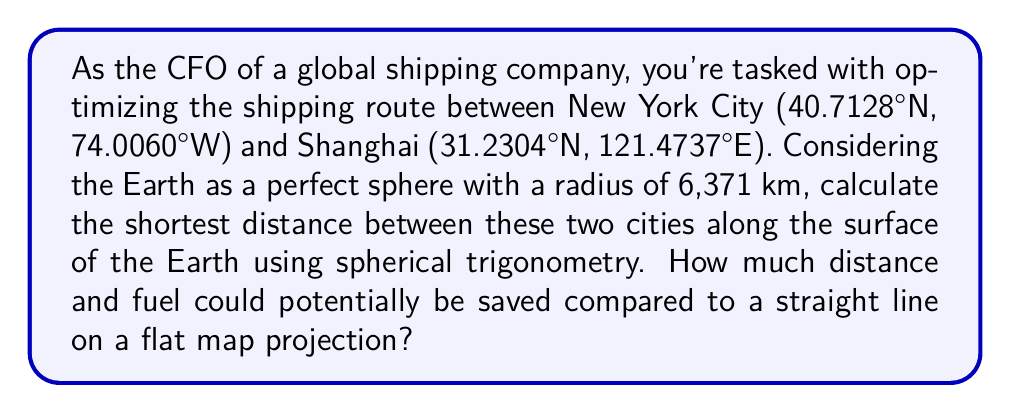Help me with this question. To solve this problem, we'll use the spherical law of cosines and compare the result to the distance on a flat map projection.

1. Convert the coordinates to radians:
   New York: $\phi_1 = 40.7128° \times \frac{\pi}{180} = 0.7101$ rad, $\lambda_1 = -74.0060° \times \frac{\pi}{180} = -1.2915$ rad
   Shanghai: $\phi_2 = 31.2304° \times \frac{\pi}{180} = 0.5451$ rad, $\lambda_2 = 121.4737° \times \frac{\pi}{180} = 2.1199$ rad

2. Calculate the central angle $\Delta\sigma$ using the spherical law of cosines:
   $$\cos(\Delta\sigma) = \sin(\phi_1)\sin(\phi_2) + \cos(\phi_1)\cos(\phi_2)\cos(\lambda_2 - \lambda_1)$$
   $$\Delta\sigma = \arccos(\sin(0.7101)\sin(0.5451) + \cos(0.7101)\cos(0.5451)\cos(2.1199 - (-1.2915)))$$
   $$\Delta\sigma = \arccos(0.1468) = 1.4238 \text{ rad}$$

3. Calculate the great circle distance:
   $$d = R \times \Delta\sigma = 6371 \times 1.4238 = 9071.5 \text{ km}$$

4. Calculate the straight-line distance on a flat map:
   $$d_{\text{flat}} = R \times \sqrt{(\phi_2 - \phi_1)^2 + (\cos(\frac{\phi_1 + \phi_2}{2})(\lambda_2 - \lambda_1))^2}$$
   $$d_{\text{flat}} = 6371 \times \sqrt{(0.5451 - 0.7101)^2 + (\cos(\frac{0.7101 + 0.5451}{2})(2.1199 - (-1.2915)))^2}$$
   $$d_{\text{flat}} = 11,135.8 \text{ km}$$

5. Calculate the difference:
   $$\text{Difference} = d_{\text{flat}} - d = 11,135.8 - 9071.5 = 2064.3 \text{ km}$$

6. Calculate the percentage saved:
   $$\text{Percentage saved} = \frac{\text{Difference}}{d_{\text{flat}}} \times 100\% = \frac{2064.3}{11,135.8} \times 100\% = 18.54\%$$
Answer: The shortest distance between New York City and Shanghai along the Earth's surface is approximately 9,071.5 km. Compared to the straight-line distance on a flat map projection (11,135.8 km), this route saves about 2,064.3 km or 18.54% in distance. Assuming fuel consumption is proportional to distance traveled, this could potentially lead to an 18.54% reduction in fuel costs for this route. 